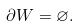Convert formula to latex. <formula><loc_0><loc_0><loc_500><loc_500>\partial W = \varnothing .</formula> 